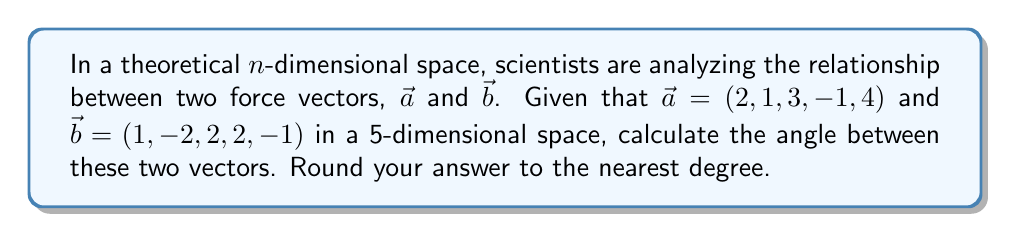What is the answer to this math problem? To find the angle between two vectors in n-dimensional space, we can use the dot product formula:

$$\cos \theta = \frac{\vec{a} \cdot \vec{b}}{|\vec{a}| |\vec{b}|}$$

Where $\theta$ is the angle between the vectors, $\vec{a} \cdot \vec{b}$ is the dot product, and $|\vec{a}|$ and $|\vec{b}|$ are the magnitudes of the vectors.

Step 1: Calculate the dot product $\vec{a} \cdot \vec{b}$
$$\vec{a} \cdot \vec{b} = (2)(1) + (1)(-2) + (3)(2) + (-1)(2) + (4)(-1) = 2 - 2 + 6 - 2 - 4 = 0$$

Step 2: Calculate the magnitudes of $\vec{a}$ and $\vec{b}$
$$|\vec{a}| = \sqrt{2^2 + 1^2 + 3^2 + (-1)^2 + 4^2} = \sqrt{4 + 1 + 9 + 1 + 16} = \sqrt{31}$$
$$|\vec{b}| = \sqrt{1^2 + (-2)^2 + 2^2 + 2^2 + (-1)^2} = \sqrt{1 + 4 + 4 + 4 + 1} = \sqrt{14}$$

Step 3: Apply the dot product formula
$$\cos \theta = \frac{0}{\sqrt{31} \sqrt{14}} = 0$$

Step 4: Solve for $\theta$
$$\theta = \arccos(0) = 90°$$

Therefore, the angle between the two vectors is 90°.
Answer: 90° 